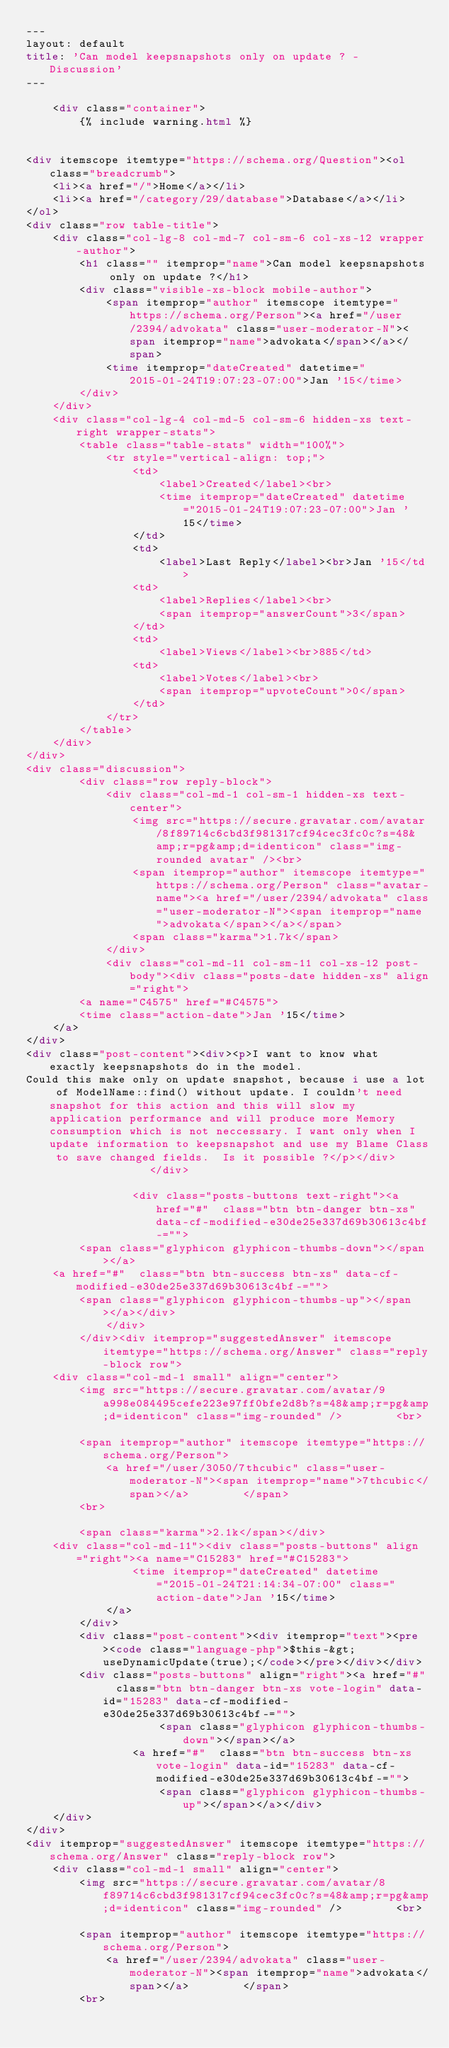Convert code to text. <code><loc_0><loc_0><loc_500><loc_500><_HTML_>---
layout: default
title: 'Can model keepsnapshots only on update ? - Discussion'
---

    <div class="container">
        {% include warning.html %}


<div itemscope itemtype="https://schema.org/Question"><ol class="breadcrumb">
    <li><a href="/">Home</a></li>
    <li><a href="/category/29/database">Database</a></li>
</ol>
<div class="row table-title">
    <div class="col-lg-8 col-md-7 col-sm-6 col-xs-12 wrapper-author">
        <h1 class="" itemprop="name">Can model keepsnapshots only on update ?</h1>
        <div class="visible-xs-block mobile-author">
            <span itemprop="author" itemscope itemtype="https://schema.org/Person"><a href="/user/2394/advokata" class="user-moderator-N"><span itemprop="name">advokata</span></a></span>
            <time itemprop="dateCreated" datetime="2015-01-24T19:07:23-07:00">Jan '15</time>
        </div>
    </div>
    <div class="col-lg-4 col-md-5 col-sm-6 hidden-xs text-right wrapper-stats">
        <table class="table-stats" width="100%">
            <tr style="vertical-align: top;">
                <td>
                    <label>Created</label><br>
                    <time itemprop="dateCreated" datetime="2015-01-24T19:07:23-07:00">Jan '15</time>
                </td>
                <td>
                    <label>Last Reply</label><br>Jan '15</td>
                <td>
                    <label>Replies</label><br>
                    <span itemprop="answerCount">3</span>
                </td>
                <td>
                    <label>Views</label><br>885</td>
                <td>
                    <label>Votes</label><br>
                    <span itemprop="upvoteCount">0</span>
                </td>
            </tr>
        </table>
    </div>
</div>
<div class="discussion">
        <div class="row reply-block">
            <div class="col-md-1 col-sm-1 hidden-xs text-center">
                <img src="https://secure.gravatar.com/avatar/8f89714c6cbd3f981317cf94cec3fc0c?s=48&amp;r=pg&amp;d=identicon" class="img-rounded avatar" /><br>
                <span itemprop="author" itemscope itemtype="https://schema.org/Person" class="avatar-name"><a href="/user/2394/advokata" class="user-moderator-N"><span itemprop="name">advokata</span></a></span>
                <span class="karma">1.7k</span>
            </div>
            <div class="col-md-11 col-sm-11 col-xs-12 post-body"><div class="posts-date hidden-xs" align="right">
        <a name="C4575" href="#C4575">
        <time class="action-date">Jan '15</time>
    </a>
</div>
<div class="post-content"><div><p>I want to know what exactly keepsnapshots do in the model.
Could this make only on update snapshot, because i use a lot of ModelName::find() without update. I couldn't need snapshot for this action and this will slow my application performance and will produce more Memory consumption which is not neccessary. I want only when I update information to keepsnapshot and use my Blame Class to save changed fields.  Is it possible ?</p></div>                </div>

                <div class="posts-buttons text-right"><a href="#"  class="btn btn-danger btn-xs" data-cf-modified-e30de25e337d69b30613c4bf-="">
        <span class="glyphicon glyphicon-thumbs-down"></span></a>
    <a href="#"  class="btn btn-success btn-xs" data-cf-modified-e30de25e337d69b30613c4bf-="">
        <span class="glyphicon glyphicon-thumbs-up"></span></a></div>
            </div>
        </div><div itemprop="suggestedAnswer" itemscope itemtype="https://schema.org/Answer" class="reply-block row">
    <div class="col-md-1 small" align="center">
        <img src="https://secure.gravatar.com/avatar/9a998e084495cefe223e97ff0bfe2d8b?s=48&amp;r=pg&amp;d=identicon" class="img-rounded" />        <br>

        <span itemprop="author" itemscope itemtype="https://schema.org/Person">
            <a href="/user/3050/7thcubic" class="user-moderator-N"><span itemprop="name">7thcubic</span></a>        </span>
        <br>

        <span class="karma">2.1k</span></div>
    <div class="col-md-11"><div class="posts-buttons" align="right"><a name="C15283" href="#C15283">
                <time itemprop="dateCreated" datetime="2015-01-24T21:14:34-07:00" class="action-date">Jan '15</time>
            </a>
        </div>
        <div class="post-content"><div itemprop="text"><pre><code class="language-php">$this-&gt;useDynamicUpdate(true);</code></pre></div></div>
        <div class="posts-buttons" align="right"><a href="#"  class="btn btn-danger btn-xs vote-login" data-id="15283" data-cf-modified-e30de25e337d69b30613c4bf-="">
                    <span class="glyphicon glyphicon-thumbs-down"></span></a>
                <a href="#"  class="btn btn-success btn-xs vote-login" data-id="15283" data-cf-modified-e30de25e337d69b30613c4bf-="">
                    <span class="glyphicon glyphicon-thumbs-up"></span></a></div>
    </div>
</div>
<div itemprop="suggestedAnswer" itemscope itemtype="https://schema.org/Answer" class="reply-block row">
    <div class="col-md-1 small" align="center">
        <img src="https://secure.gravatar.com/avatar/8f89714c6cbd3f981317cf94cec3fc0c?s=48&amp;r=pg&amp;d=identicon" class="img-rounded" />        <br>

        <span itemprop="author" itemscope itemtype="https://schema.org/Person">
            <a href="/user/2394/advokata" class="user-moderator-N"><span itemprop="name">advokata</span></a>        </span>
        <br>
</code> 